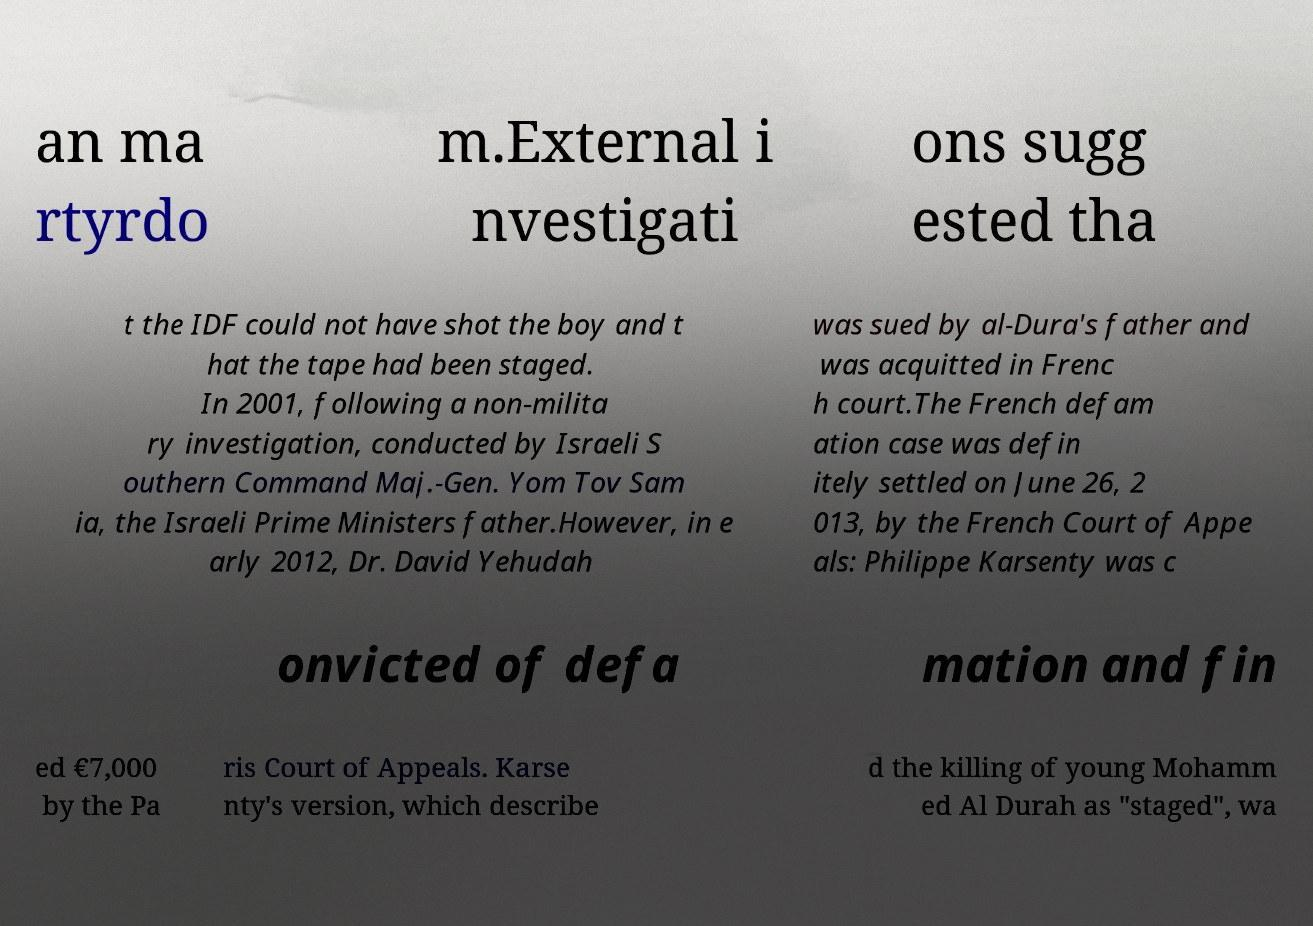Please identify and transcribe the text found in this image. an ma rtyrdo m.External i nvestigati ons sugg ested tha t the IDF could not have shot the boy and t hat the tape had been staged. In 2001, following a non-milita ry investigation, conducted by Israeli S outhern Command Maj.-Gen. Yom Tov Sam ia, the Israeli Prime Ministers father.However, in e arly 2012, Dr. David Yehudah was sued by al-Dura's father and was acquitted in Frenc h court.The French defam ation case was defin itely settled on June 26, 2 013, by the French Court of Appe als: Philippe Karsenty was c onvicted of defa mation and fin ed €7,000 by the Pa ris Court of Appeals. Karse nty's version, which describe d the killing of young Mohamm ed Al Durah as "staged", wa 